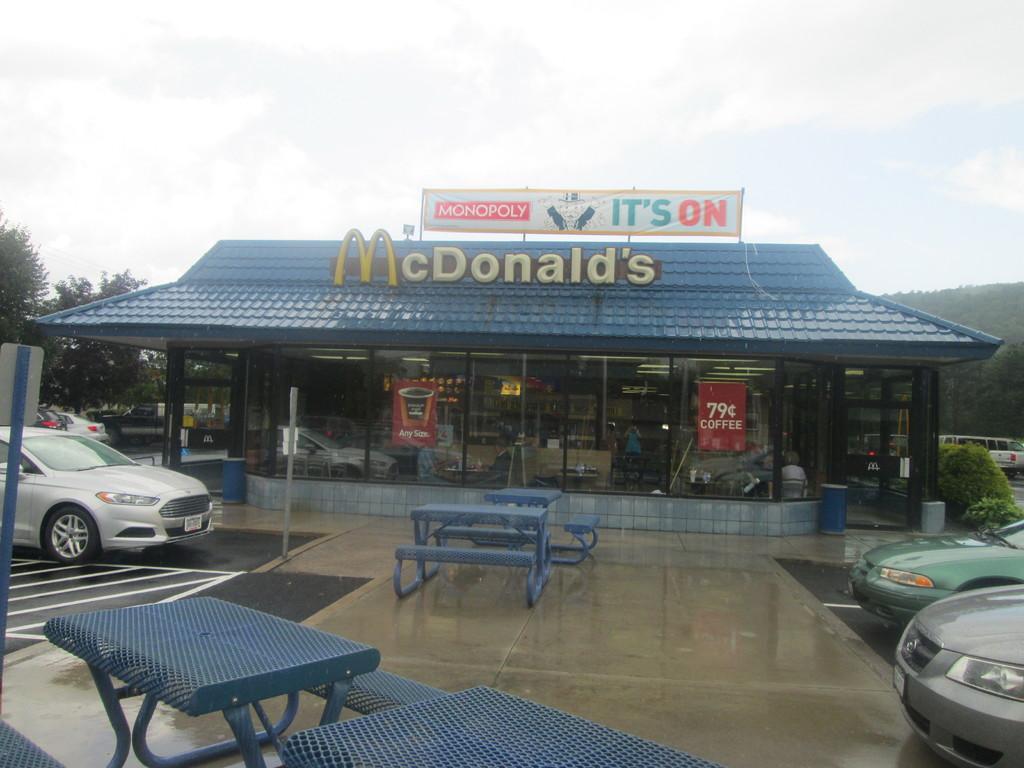In one or two sentences, can you explain what this image depicts? In this picture we can see a store, on the right side and left side there are cars, we can see benches and tables in the middle, in the background there are some trees, we can see glasses and a hoarding of this store, there are two papers pasted on these glasses, on the right side there are some plants, we can see the sky at the top of the picture, on the left side there is a board. 